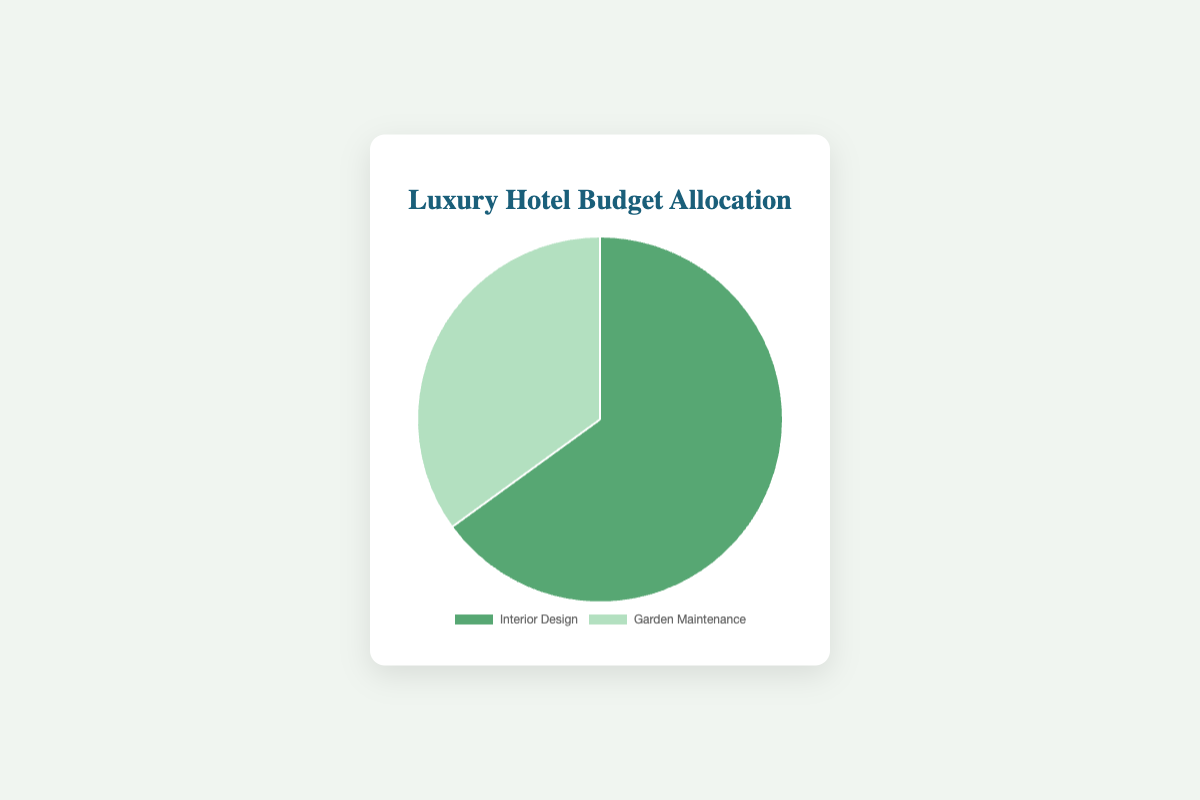Which category receives the highest budget allocation? The figure shows a pie chart with two slices labeled "Interior Design" and "Garden Maintenance." The slice for "Interior Design" has a larger proportion.
Answer: Interior Design What percentage of the budget is allocated to Garden Maintenance? The figure indicates the percentage inside the pie chart slice associated with "Garden Maintenance."
Answer: 35% How much more budget percentage is allocated to Interior Design compared to Garden Maintenance? Subtract the percentage of "Garden Maintenance" from the percentage of "Interior Design" (65% - 35%).
Answer: 30% What fraction of the budget is allocated to Garden Maintenance as compared to the total budget? The total budget represents 100%, and "Garden Maintenance" constitutes 35% of this. Therefore, the fraction is 35/100.
Answer: 0.35 By how many percentage points does the budget allocation for Interior Design exceed that for Garden Maintenance? Subtract 35% (Garden Maintenance) from 65% (Interior Design) to get the difference in percentage points.
Answer: 30 percentage points What are the colors used to represent Interior Design and Garden Maintenance in the pie chart? The slice for "Interior Design" is greenish (#57a773) and the slice for "Garden Maintenance" is light greenish (#b3e0c0).
Answer: Green and Light Green If the total budget were $100,000, what would be the exact amount allocated to Interior Design? Multiply the total budget by the percentage allocated to "Interior Design" (100,000 * 0.65).
Answer: $65,000 If the budget for Garden Maintenance is cut by 5%, what would be its new budget percentage? Subtract 5% from the initial 35% allocated to "Garden Maintenance" (35% - 5%).
Answer: 30% Given that the budget for Garden Maintenance increases by 10%, how would the budget allocation percentage change? Add 10% to the initial 35% allocated (35% + 10%).
Answer: 45% What is the sum of the percentages allocated to both Interior Design and Garden Maintenance? Add the percentages for "Interior Design" and "Garden Maintenance" (65% + 35%).
Answer: 100% 